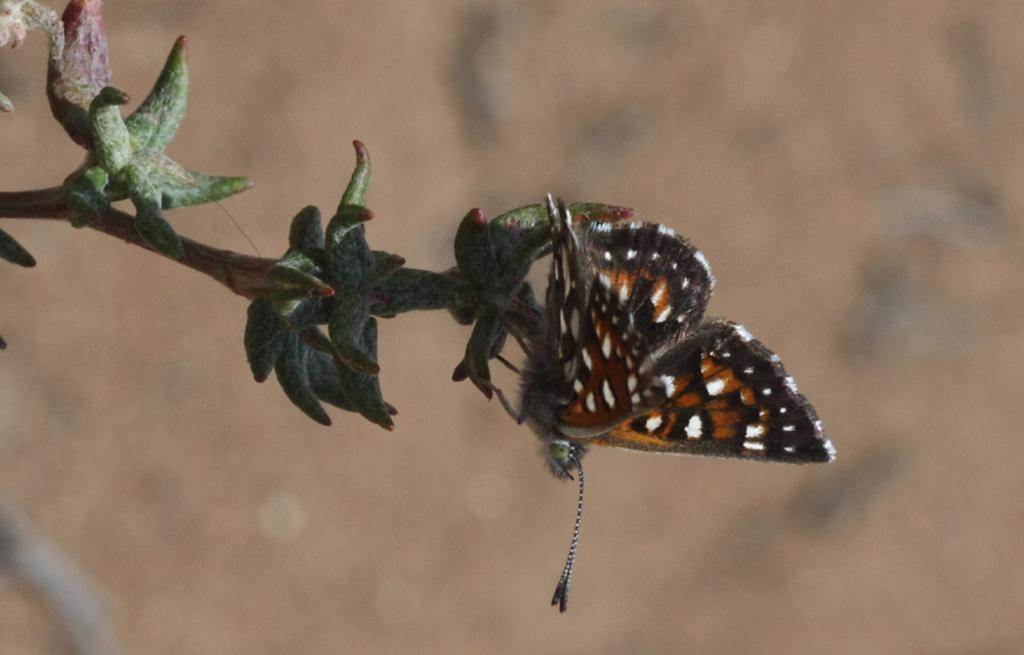Could you give a brief overview of what you see in this image? In this image I can see a butterfly which is brown, black and white in color on a tree which is green in color. I can see the blurry background which is brown in color. 